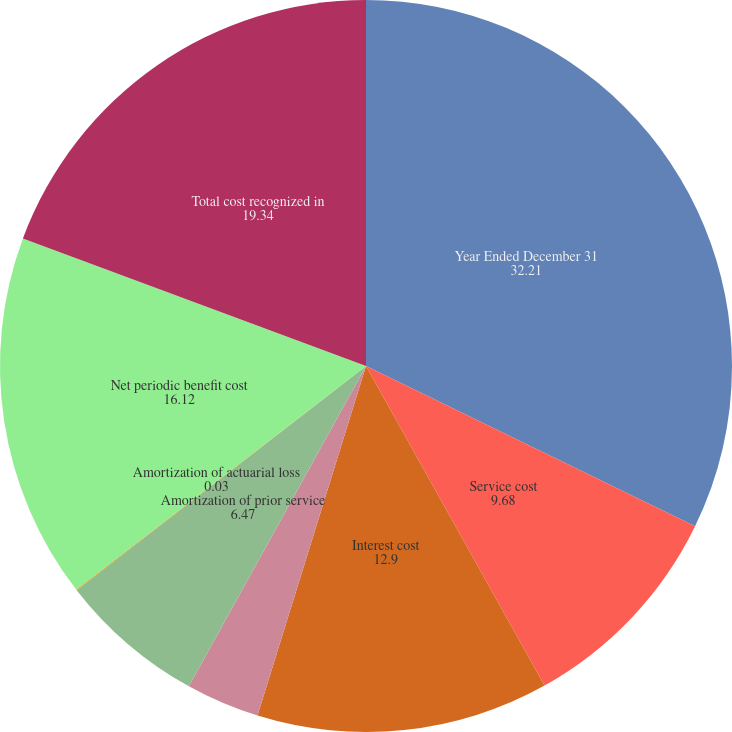<chart> <loc_0><loc_0><loc_500><loc_500><pie_chart><fcel>Year Ended December 31<fcel>Service cost<fcel>Interest cost<fcel>Expected return on plan assets<fcel>Amortization of prior service<fcel>Amortization of actuarial loss<fcel>Net periodic benefit cost<fcel>Total cost recognized in<nl><fcel>32.21%<fcel>9.68%<fcel>12.9%<fcel>3.25%<fcel>6.47%<fcel>0.03%<fcel>16.12%<fcel>19.34%<nl></chart> 